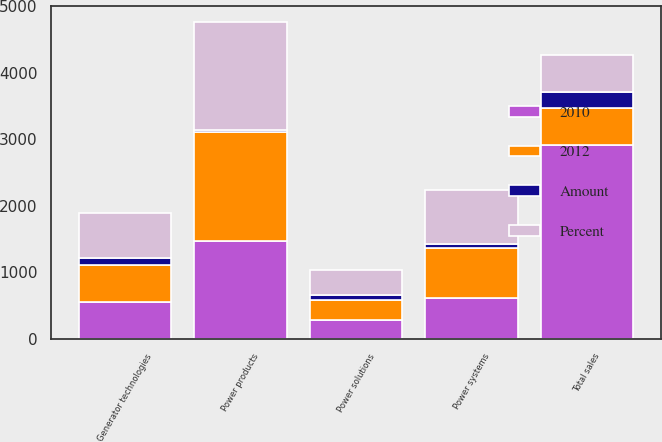Convert chart. <chart><loc_0><loc_0><loc_500><loc_500><stacked_bar_chart><ecel><fcel>Power products<fcel>Power systems<fcel>Generator technologies<fcel>Power solutions<fcel>Total sales<nl><fcel>2012<fcel>1654<fcel>757<fcel>566<fcel>291<fcel>558<nl><fcel>Percent<fcel>1636<fcel>815<fcel>673<fcel>374<fcel>558<nl><fcel>2010<fcel>1465<fcel>616<fcel>550<fcel>288<fcel>2919<nl><fcel>Amount<fcel>18<fcel>58<fcel>107<fcel>83<fcel>230<nl></chart> 